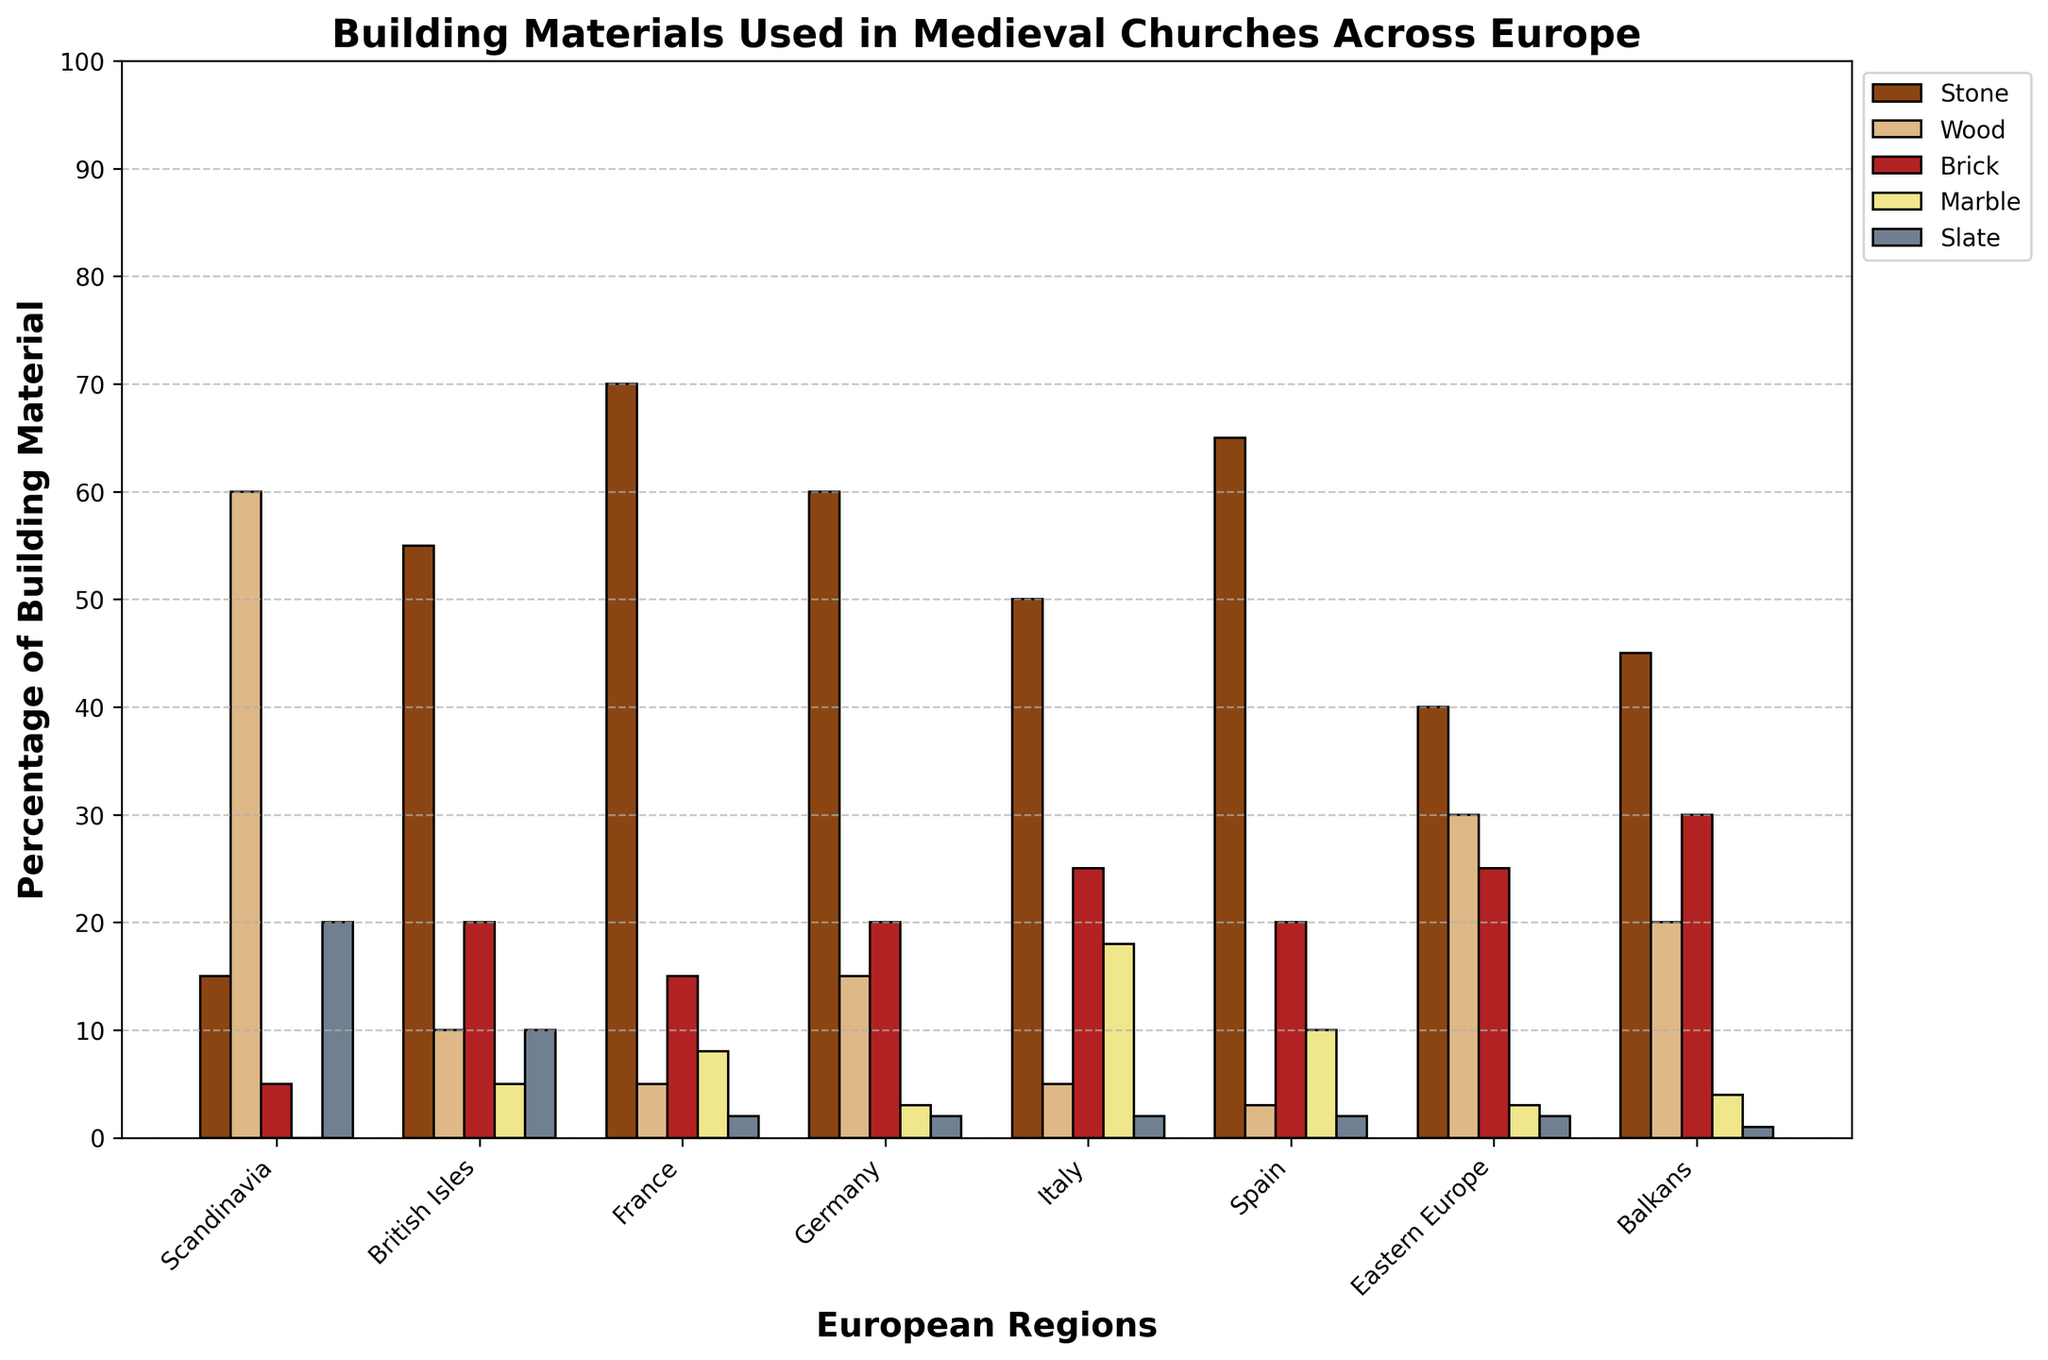Which region uses the least amount of wood in their medieval churches? The region that uses the least amount of wood can be identified by looking for the shortest bar representing wood across all regions. The shortest bar belongs to Spain with only 3%.
Answer: Spain Which two regions have the closest percentage of stone used in church construction? Compare the heights of the stone bars for each region and look for two bars with closely matching heights. France and Spain both use a similar percentage, with France at 70% and Spain at 65%.
Answer: France and Spain What's the total percentage of marble used in church construction in Italy and Spain combined? Add the height of the marble bar for Italy (18%) to the height of the marble bar for Spain (10%). 18% + 10% = 28%.
Answer: 28% Which region has the most diverse range of building materials in terms of relative proportions? To determine this, look for a region with the most equal distribution of bar heights across materials. The Balkans have a relatively balanced distribution with stone (45%), wood (20%), brick (30%), marble (4%), and slate (1%).
Answer: Balkans Which region uses more slate, Scandinavia or British Isles? Compare the height of the slate bars for both regions. Scandinavia has 20% slate, while the British Isles has 10%. Therefore, Scandinavia uses more slate.
Answer: Scandinavia What’s the difference in the percentage of stone used between France and Germany? Subtract the percentage of stone in Germany (60%) from the percentage of stone in France (70%). 70% - 60% = 10%.
Answer: 10% What is the average percentage use of brick across all regions? Sum the percentage values for brick across all regions and then divide by the number of regions (8). (5 + 20 + 15 + 20 + 25 + 20 + 25 + 30) / 8 = 20%.
Answer: 20% Which material is least used in the British Isles and what percentage does it make up? Identify the shortest bar for the British Isles and read its label and height. The shortest bar represents wood, which is at 10%.
Answer: Wood, 10% In which regions does wood account for more than 20% of the building material? Look at all the bars for wood and identify the regions where the wood bar is greater than 20%. Only Scandinavia (60%) and Eastern Europe (30%) meet this criterion.
Answer: Scandinavia and Eastern Europe How much more marble does Italy use compared to France? Subtract the percentage of marble in France (8%) from the percentage of marble in Italy (18%). 18% - 8% = 10%.
Answer: 10% 